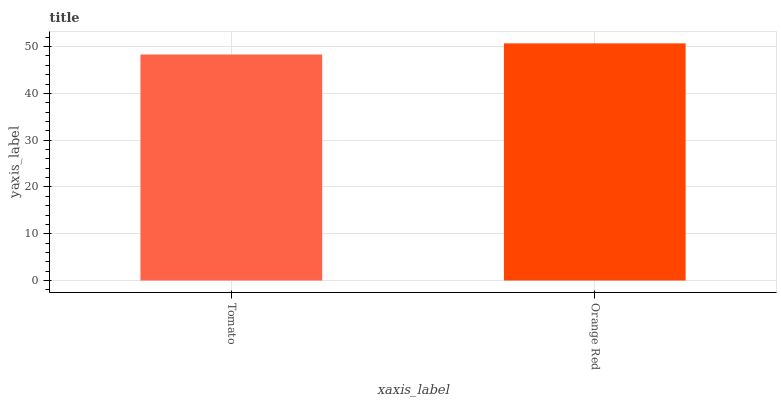Is Tomato the minimum?
Answer yes or no. Yes. Is Orange Red the maximum?
Answer yes or no. Yes. Is Orange Red the minimum?
Answer yes or no. No. Is Orange Red greater than Tomato?
Answer yes or no. Yes. Is Tomato less than Orange Red?
Answer yes or no. Yes. Is Tomato greater than Orange Red?
Answer yes or no. No. Is Orange Red less than Tomato?
Answer yes or no. No. Is Orange Red the high median?
Answer yes or no. Yes. Is Tomato the low median?
Answer yes or no. Yes. Is Tomato the high median?
Answer yes or no. No. Is Orange Red the low median?
Answer yes or no. No. 